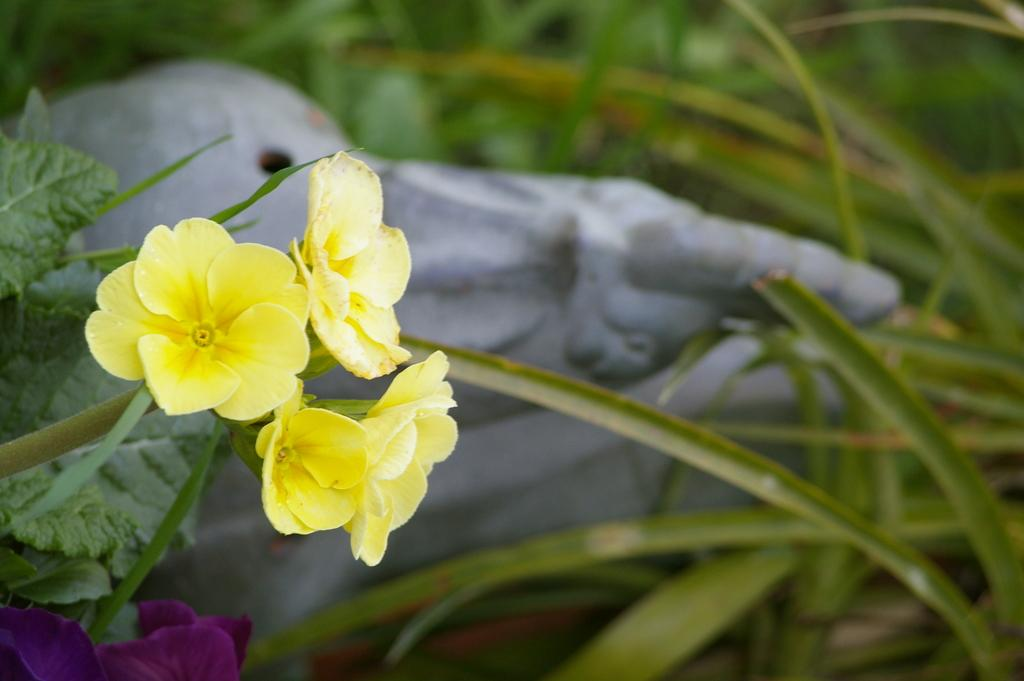What types of plants can be seen in the foreground of the image? There are flowering plants in the foreground of the image. What other elements are present in the foreground of the image? There is a stone and grass visible in the foreground of the image. Can you describe the setting where the image might have been taken? The image may have been taken in a park, given the presence of flowering plants, grass, and possibly other park-like features. What type of eggnog is being served in the image? There is no eggnog present in the image; it features flowering plants, a stone, and grass in a possible park setting. 